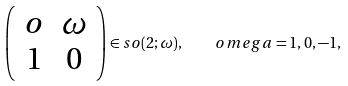Convert formula to latex. <formula><loc_0><loc_0><loc_500><loc_500>\left ( \begin{array} { c c } o & \omega \\ 1 & 0 \end{array} \right ) \in s o ( 2 ; \omega ) , \quad o m e g a = 1 , 0 , - 1 ,</formula> 